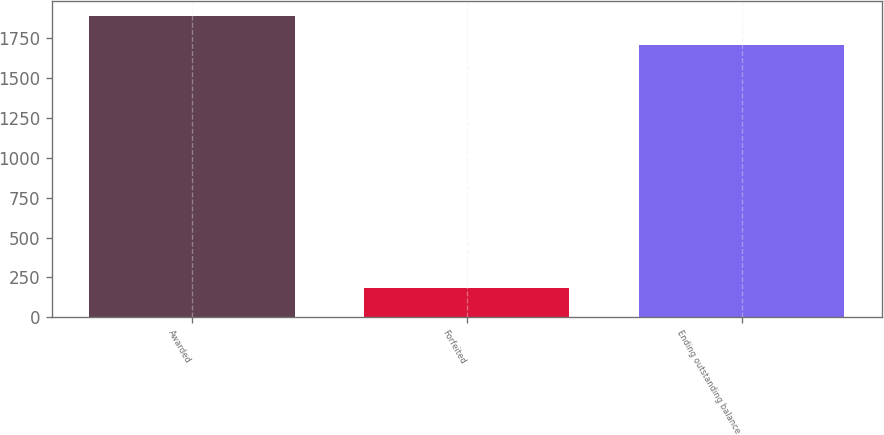Convert chart. <chart><loc_0><loc_0><loc_500><loc_500><bar_chart><fcel>Awarded<fcel>Forfeited<fcel>Ending outstanding balance<nl><fcel>1891<fcel>184<fcel>1707<nl></chart> 